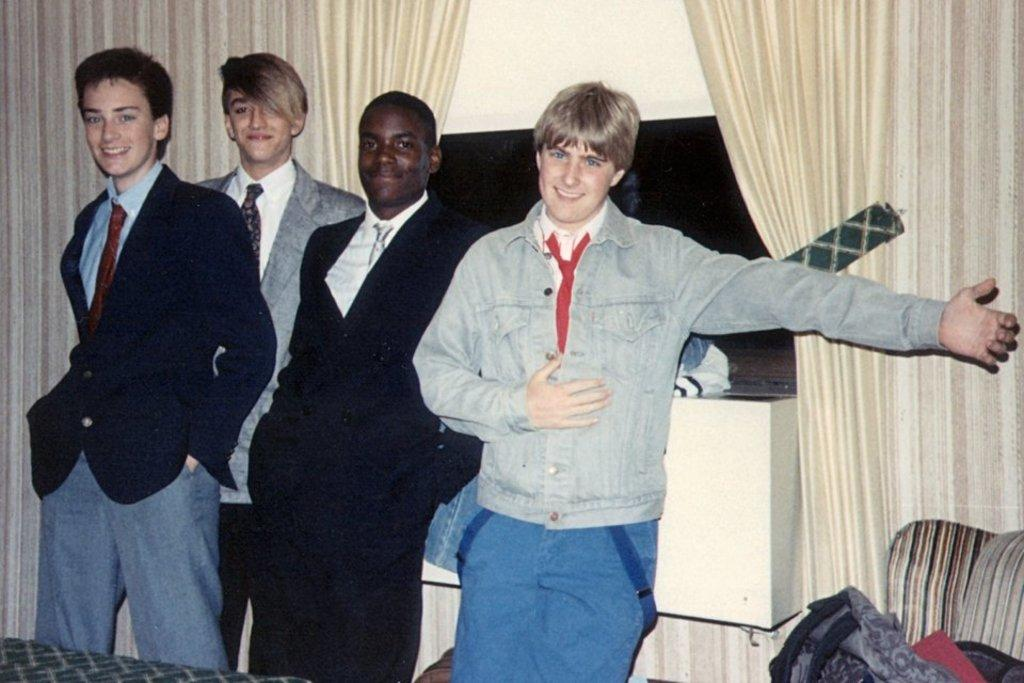Who or what can be seen in the image? There are people in the image. What is visible in the background of the image? There is a wall and curtains in the background of the image. What type of stitch is being used to sew the railway in the image? There is no railway or stitching present in the image. What is the level of interest in the image? The level of interest cannot be determined from the image itself, as it is a subjective measure. 